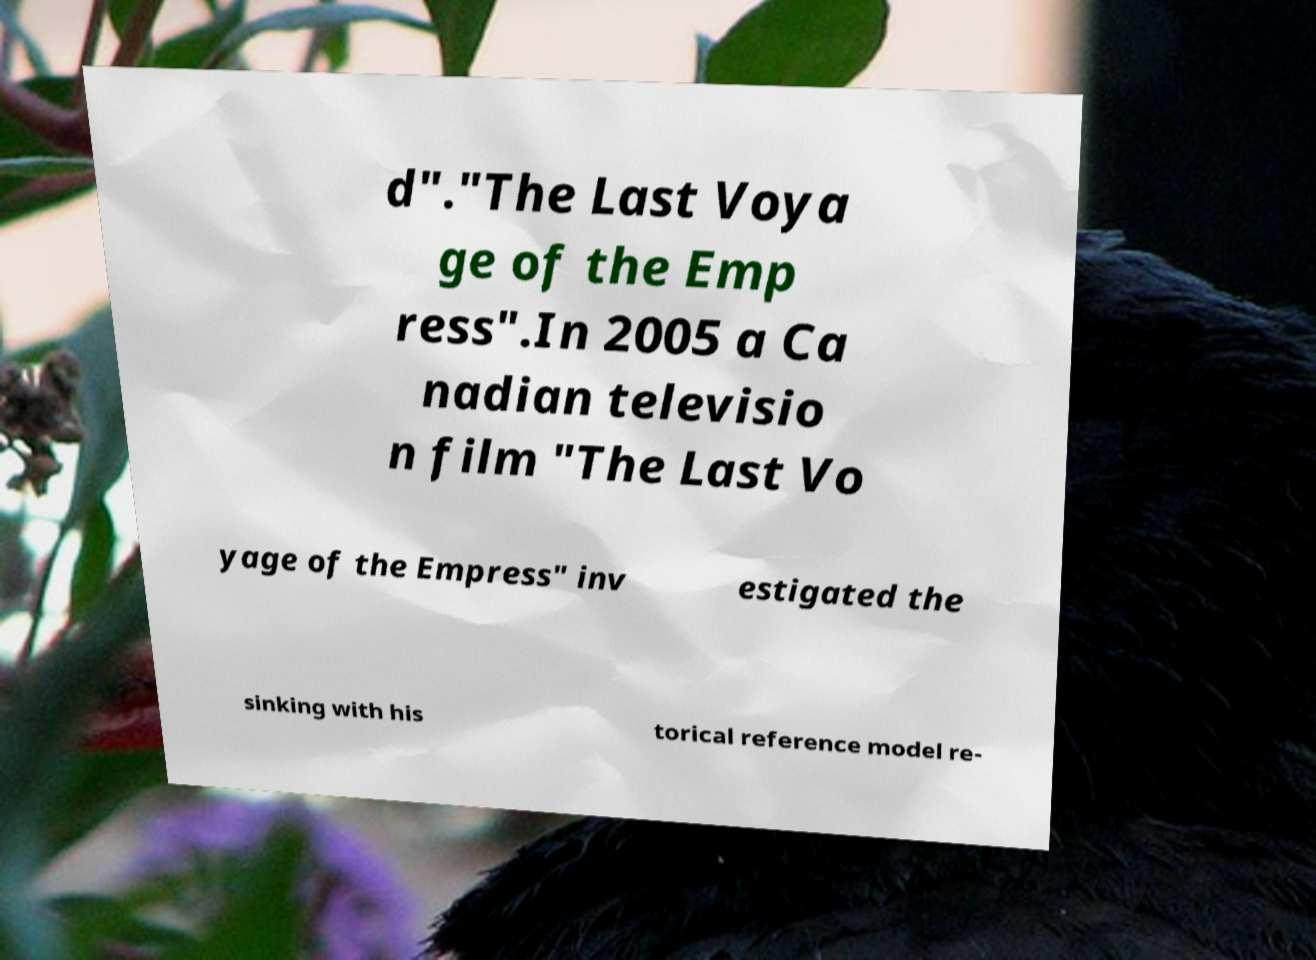There's text embedded in this image that I need extracted. Can you transcribe it verbatim? d"."The Last Voya ge of the Emp ress".In 2005 a Ca nadian televisio n film "The Last Vo yage of the Empress" inv estigated the sinking with his torical reference model re- 